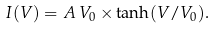Convert formula to latex. <formula><loc_0><loc_0><loc_500><loc_500>I ( V ) = A \, V _ { 0 } \times \tanh ( V / V _ { 0 } ) .</formula> 